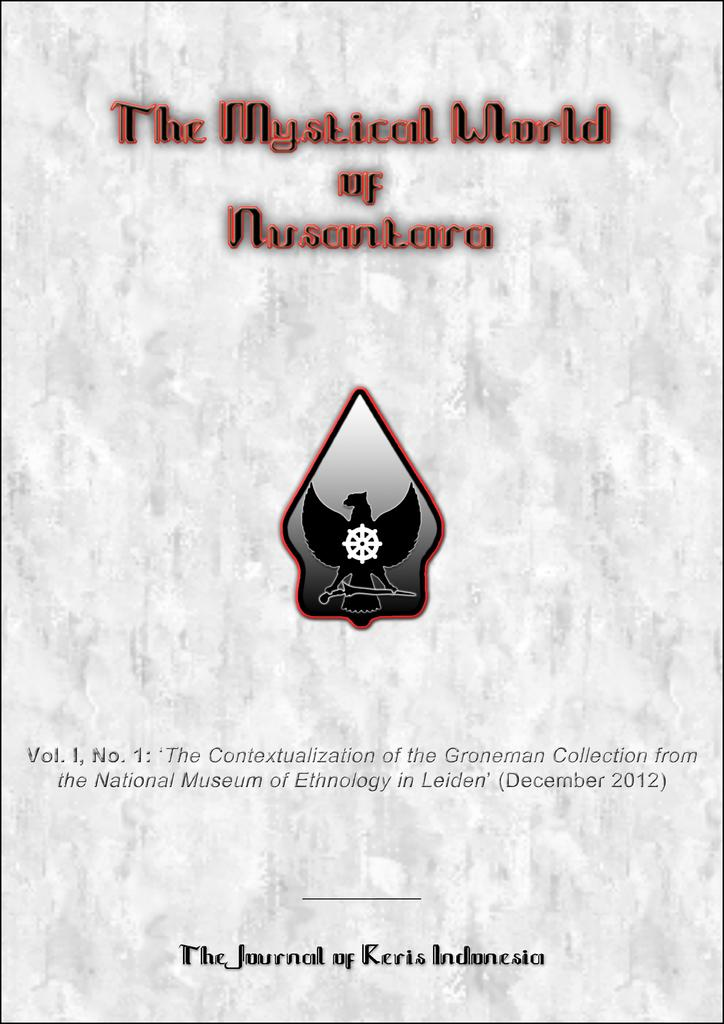Provide a one-sentence caption for the provided image. white book the mystical world of nusantara that has bird symbol on it. 